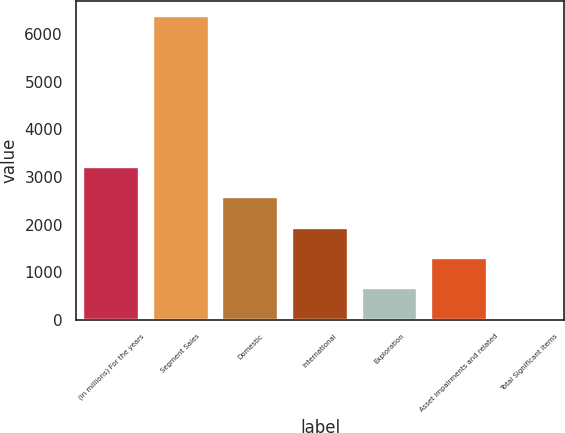<chart> <loc_0><loc_0><loc_500><loc_500><bar_chart><fcel>(in millions) For the years<fcel>Segment Sales<fcel>Domestic<fcel>International<fcel>Exploration<fcel>Asset impairments and related<fcel>Total Significant Items<nl><fcel>3206.5<fcel>6377<fcel>2572.4<fcel>1938.3<fcel>670.1<fcel>1304.2<fcel>36<nl></chart> 